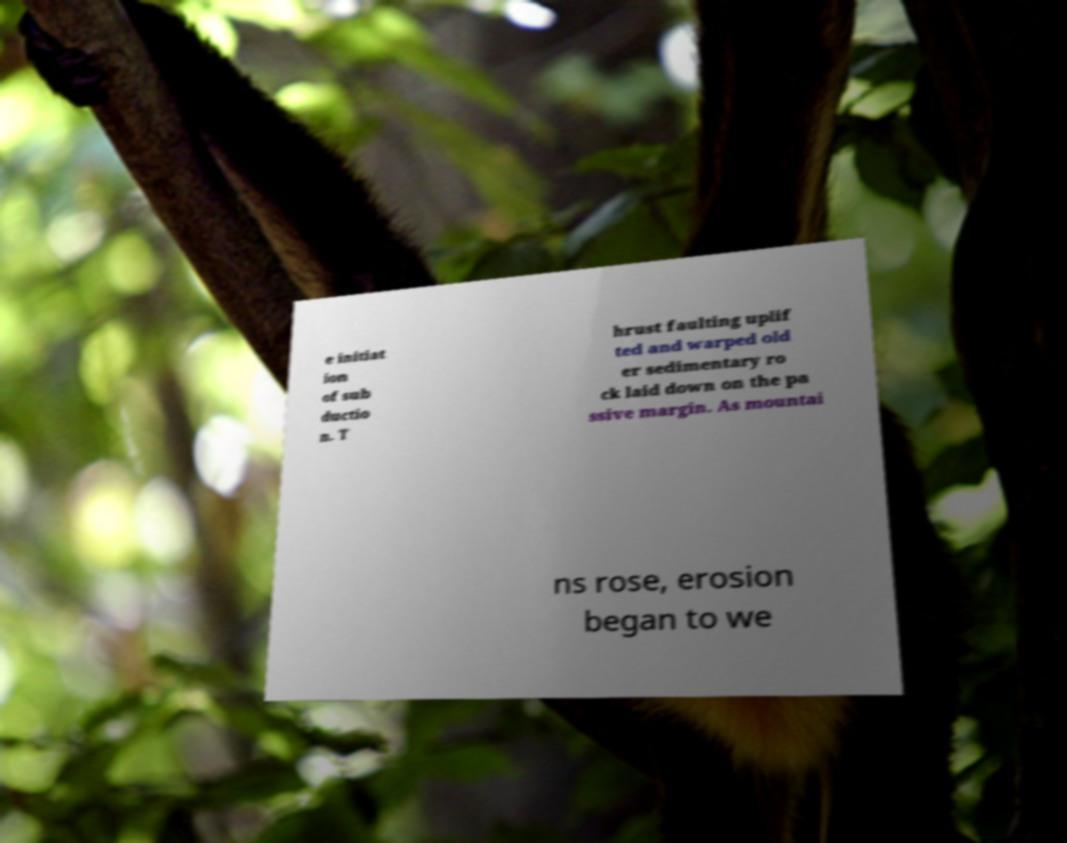For documentation purposes, I need the text within this image transcribed. Could you provide that? e initiat ion of sub ductio n. T hrust faulting uplif ted and warped old er sedimentary ro ck laid down on the pa ssive margin. As mountai ns rose, erosion began to we 